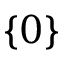<formula> <loc_0><loc_0><loc_500><loc_500>\{ 0 \}</formula> 